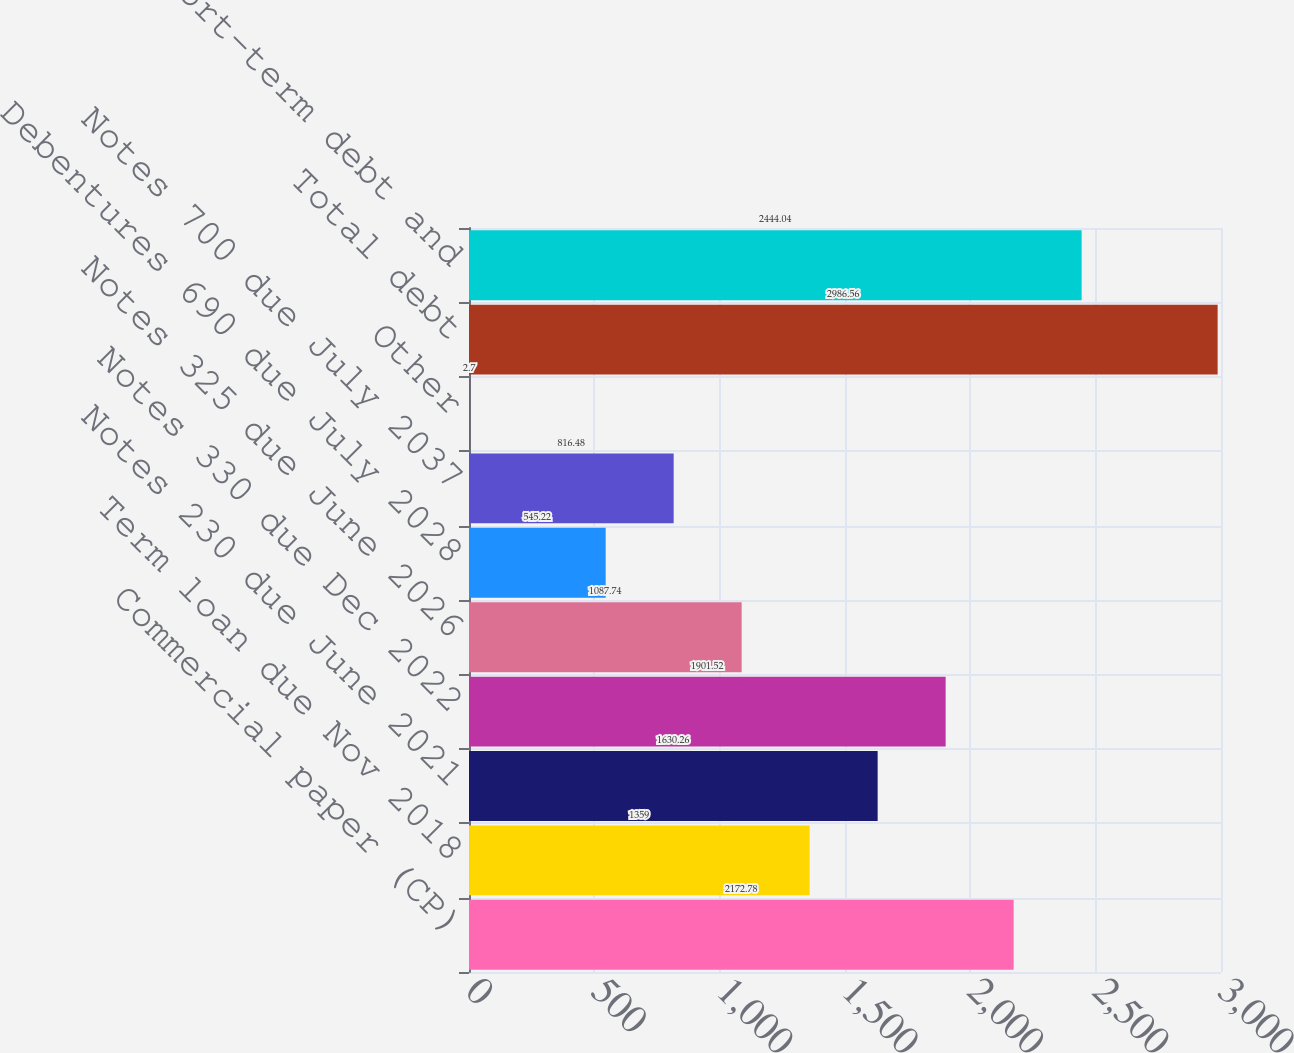Convert chart to OTSL. <chart><loc_0><loc_0><loc_500><loc_500><bar_chart><fcel>Commercial paper (CP)<fcel>Term loan due Nov 2018<fcel>Notes 230 due June 2021<fcel>Notes 330 due Dec 2022<fcel>Notes 325 due June 2026<fcel>Debentures 690 due July 2028<fcel>Notes 700 due July 2037<fcel>Other<fcel>Total debt<fcel>Less short-term debt and<nl><fcel>2172.78<fcel>1359<fcel>1630.26<fcel>1901.52<fcel>1087.74<fcel>545.22<fcel>816.48<fcel>2.7<fcel>2986.56<fcel>2444.04<nl></chart> 